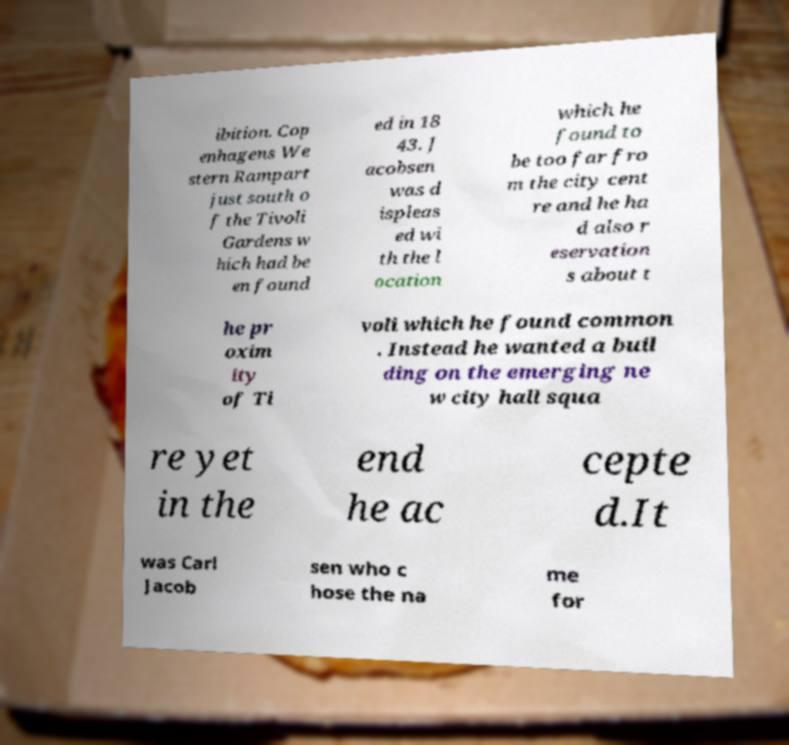Can you accurately transcribe the text from the provided image for me? ibition. Cop enhagens We stern Rampart just south o f the Tivoli Gardens w hich had be en found ed in 18 43. J acobsen was d ispleas ed wi th the l ocation which he found to be too far fro m the city cent re and he ha d also r eservation s about t he pr oxim ity of Ti voli which he found common . Instead he wanted a buil ding on the emerging ne w city hall squa re yet in the end he ac cepte d.It was Carl Jacob sen who c hose the na me for 